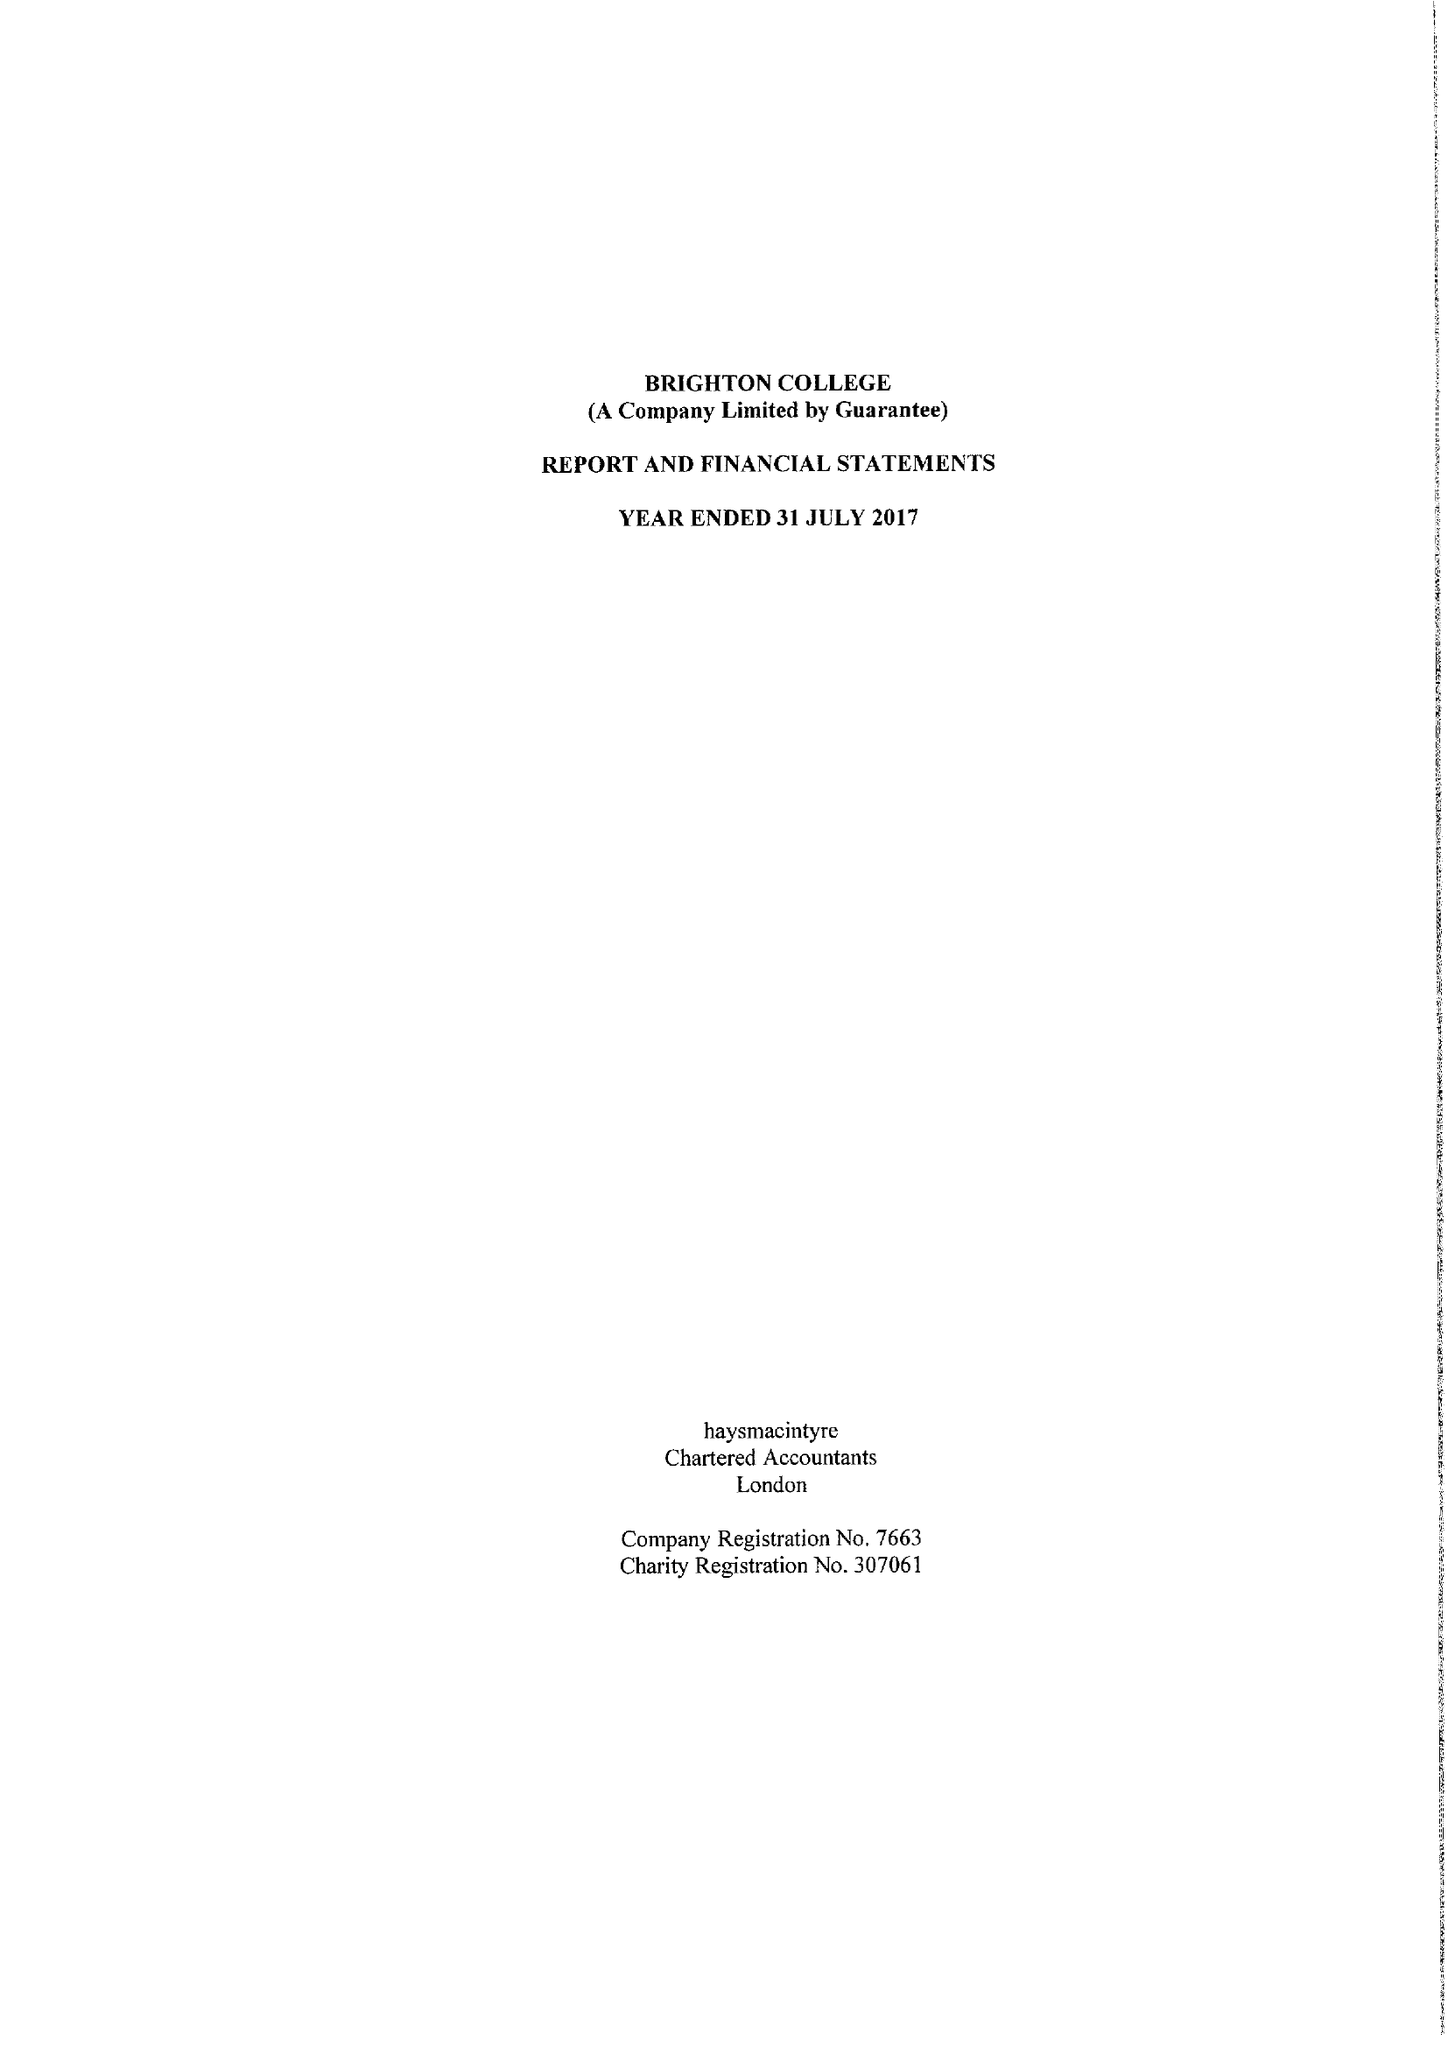What is the value for the income_annually_in_british_pounds?
Answer the question using a single word or phrase. 47944392.00 